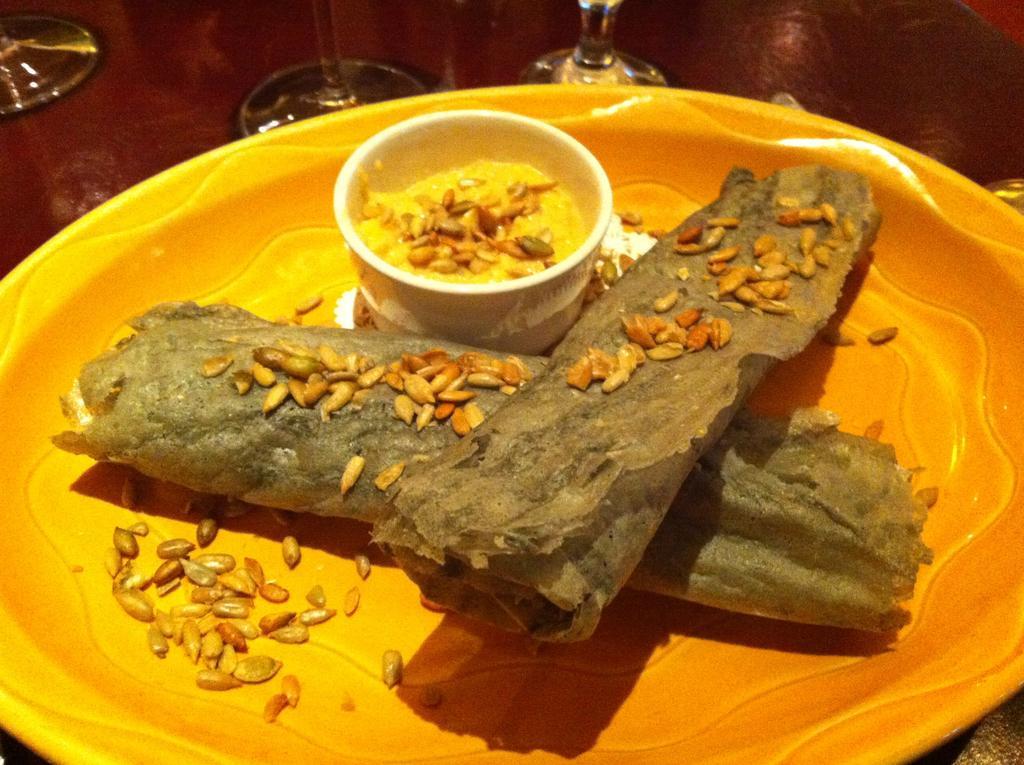How would you summarize this image in a sentence or two? In this image there is a food item and a bowl placed on a plate, in front of the plate there are glasses. 